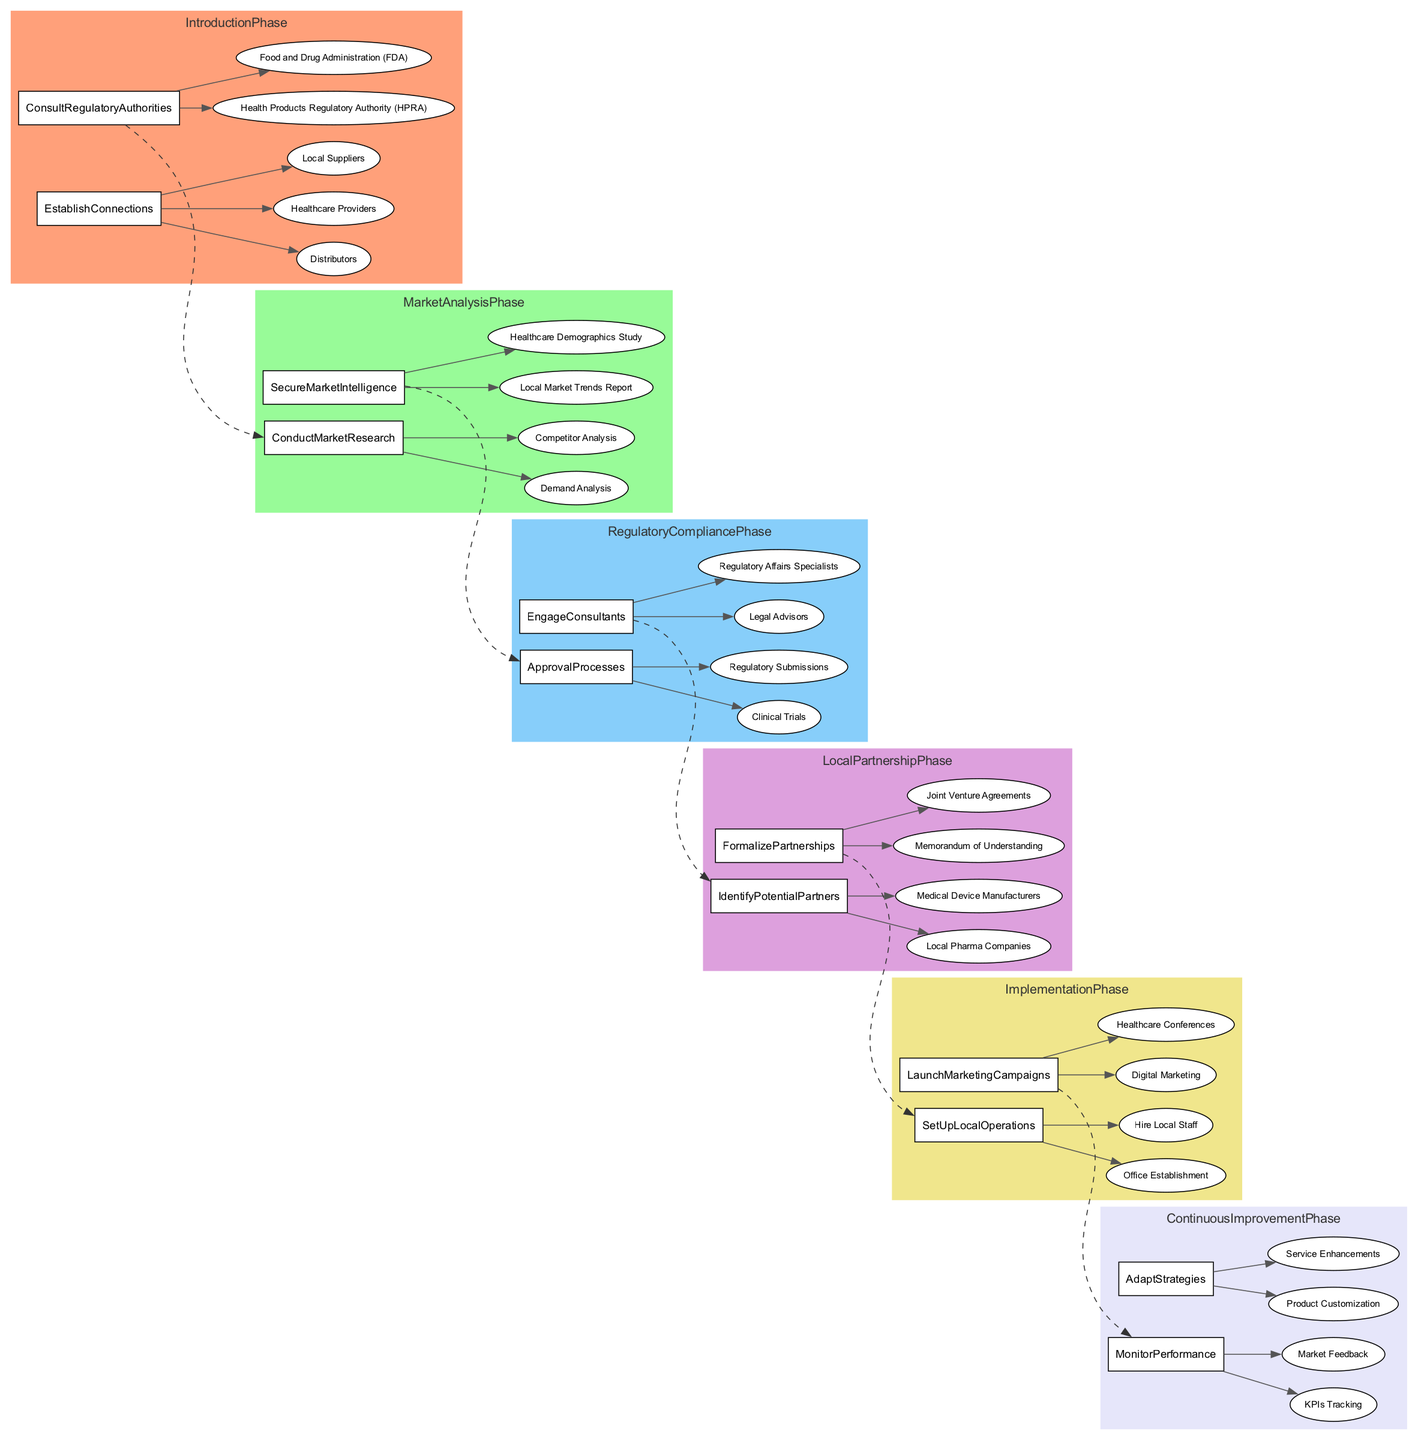What are the main phases in the Clinical Pathway? The diagram outlines six main phases: Introduction Phase, Market Analysis Phase, Regulatory Compliance Phase, Local Partnership Phase, Implementation Phase, and Continuous Improvement Phase.
Answer: Introduction Phase, Market Analysis Phase, Regulatory Compliance Phase, Local Partnership Phase, Implementation Phase, Continuous Improvement Phase Which authority should be consulted during the Introduction Phase? The diagram specifies two regulatory authorities to consult during the Introduction Phase: the Health Products Regulatory Authority (HPRA) and the Food and Drug Administration (FDA).
Answer: Health Products Regulatory Authority (HPRA), Food and Drug Administration (FDA) How many activities are listed in the Local Partnership Phase? In the Local Partnership Phase, there are two activities: Identify Potential Partners and Formalize Partnerships. Hence, the count of activities here is two.
Answer: 2 What is the last activity listed in the Implementation Phase? The Implementation Phase concludes with the activity of launching marketing campaigns, specifically focusing on Digital Marketing and Healthcare Conferences, where the last activity is indicated as Launch Marketing Campaigns.
Answer: Launch Marketing Campaigns What connects the Regulatory Compliance Phase to the Local Partnership Phase? The connection between the Regulatory Compliance Phase and the Local Partnership Phase is represented by a dashed edge indicating a flow from the last activity in the Regulatory Compliance Phase, named Engage Consultants, to the first activity in the Local Partnership Phase, which is Identify Potential Partners.
Answer: Engage Consultants to Identify Potential Partners Which task involves tracking market performance in the Continuous Improvement Phase? In the Continuous Improvement Phase, the task focused on monitoring market performance is referred to as KPIs Tracking. This indicates its specific role in performance assessment during this phase.
Answer: KPIs Tracking What are the activities involved in the Market Analysis Phase? The Market Analysis Phase involves two key activities: Conduct Market Research and Secure Market Intelligence. These activities encompass various tasks essential for understanding the market landscape.
Answer: Conduct Market Research, Secure Market Intelligence How many tasks are listed under the Approval Processes in the Regulatory Compliance Phase? Under the Approval Processes in the Regulatory Compliance Phase, there are two tasks outlined: Clinical Trials and Regulatory Submissions, thus totaling two tasks in this category.
Answer: 2 